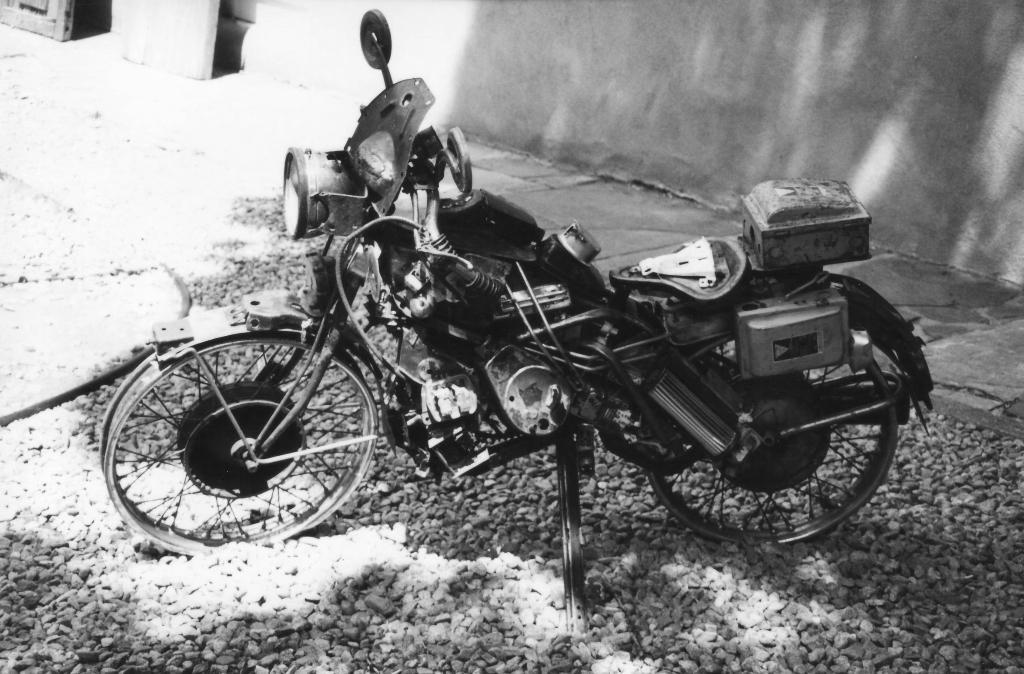What type of vehicle is in the image? There is an old motorcycle in the image. What can be seen on the ground in the image? There are stones on the ground in the image. What structure is visible in the image? There is a wall visible in the image. What type of fiction is being read by the men in the image? There are no men or fiction present in the image; it features an old motorcycle, stones on the ground, and a wall. 